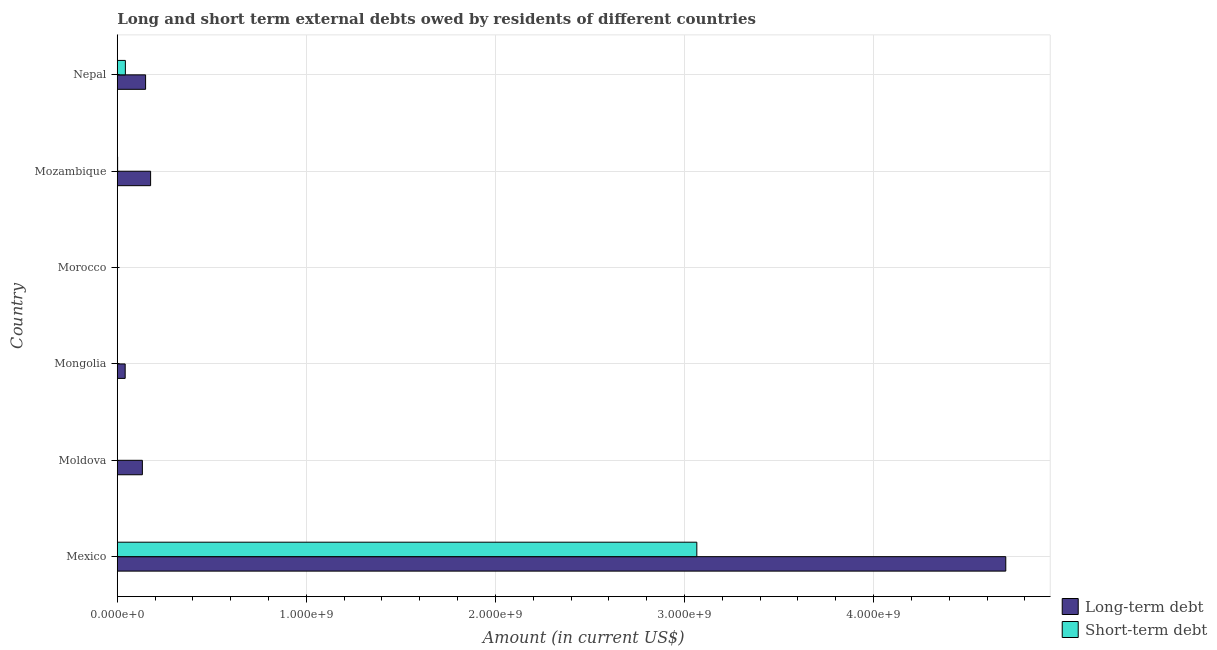What is the label of the 6th group of bars from the top?
Your answer should be compact. Mexico. In how many cases, is the number of bars for a given country not equal to the number of legend labels?
Offer a terse response. 2. What is the long-term debts owed by residents in Moldova?
Make the answer very short. 1.33e+08. Across all countries, what is the maximum short-term debts owed by residents?
Offer a very short reply. 3.07e+09. Across all countries, what is the minimum short-term debts owed by residents?
Your answer should be compact. 0. What is the total short-term debts owed by residents in the graph?
Provide a short and direct response. 3.11e+09. What is the difference between the long-term debts owed by residents in Moldova and that in Mozambique?
Offer a terse response. -4.35e+07. What is the difference between the long-term debts owed by residents in Moldova and the short-term debts owed by residents in Morocco?
Make the answer very short. 1.33e+08. What is the average short-term debts owed by residents per country?
Provide a short and direct response. 5.18e+08. What is the difference between the long-term debts owed by residents and short-term debts owed by residents in Mexico?
Offer a very short reply. 1.63e+09. What is the ratio of the long-term debts owed by residents in Mongolia to that in Mozambique?
Offer a terse response. 0.24. What is the difference between the highest and the second highest long-term debts owed by residents?
Give a very brief answer. 4.52e+09. What is the difference between the highest and the lowest long-term debts owed by residents?
Offer a terse response. 4.70e+09. In how many countries, is the long-term debts owed by residents greater than the average long-term debts owed by residents taken over all countries?
Keep it short and to the point. 1. Is the sum of the long-term debts owed by residents in Moldova and Mongolia greater than the maximum short-term debts owed by residents across all countries?
Your response must be concise. No. Are all the bars in the graph horizontal?
Your answer should be very brief. Yes. How many countries are there in the graph?
Your response must be concise. 6. What is the difference between two consecutive major ticks on the X-axis?
Offer a very short reply. 1.00e+09. Are the values on the major ticks of X-axis written in scientific E-notation?
Provide a succinct answer. Yes. Does the graph contain any zero values?
Your answer should be very brief. Yes. Does the graph contain grids?
Make the answer very short. Yes. What is the title of the graph?
Provide a short and direct response. Long and short term external debts owed by residents of different countries. What is the label or title of the X-axis?
Offer a terse response. Amount (in current US$). What is the Amount (in current US$) in Long-term debt in Mexico?
Provide a succinct answer. 4.70e+09. What is the Amount (in current US$) of Short-term debt in Mexico?
Offer a terse response. 3.07e+09. What is the Amount (in current US$) of Long-term debt in Moldova?
Ensure brevity in your answer.  1.33e+08. What is the Amount (in current US$) of Short-term debt in Moldova?
Make the answer very short. 1.00e+06. What is the Amount (in current US$) of Long-term debt in Mongolia?
Give a very brief answer. 4.17e+07. What is the Amount (in current US$) of Short-term debt in Mongolia?
Provide a short and direct response. 0. What is the Amount (in current US$) of Long-term debt in Mozambique?
Give a very brief answer. 1.76e+08. What is the Amount (in current US$) in Short-term debt in Mozambique?
Offer a very short reply. 1.80e+06. What is the Amount (in current US$) in Long-term debt in Nepal?
Ensure brevity in your answer.  1.50e+08. What is the Amount (in current US$) in Short-term debt in Nepal?
Provide a succinct answer. 4.28e+07. Across all countries, what is the maximum Amount (in current US$) of Long-term debt?
Provide a succinct answer. 4.70e+09. Across all countries, what is the maximum Amount (in current US$) of Short-term debt?
Ensure brevity in your answer.  3.07e+09. What is the total Amount (in current US$) of Long-term debt in the graph?
Your response must be concise. 5.20e+09. What is the total Amount (in current US$) of Short-term debt in the graph?
Your response must be concise. 3.11e+09. What is the difference between the Amount (in current US$) of Long-term debt in Mexico and that in Moldova?
Your answer should be very brief. 4.57e+09. What is the difference between the Amount (in current US$) in Short-term debt in Mexico and that in Moldova?
Offer a terse response. 3.06e+09. What is the difference between the Amount (in current US$) in Long-term debt in Mexico and that in Mongolia?
Your answer should be compact. 4.66e+09. What is the difference between the Amount (in current US$) in Long-term debt in Mexico and that in Mozambique?
Your answer should be compact. 4.52e+09. What is the difference between the Amount (in current US$) of Short-term debt in Mexico and that in Mozambique?
Keep it short and to the point. 3.06e+09. What is the difference between the Amount (in current US$) of Long-term debt in Mexico and that in Nepal?
Offer a very short reply. 4.55e+09. What is the difference between the Amount (in current US$) in Short-term debt in Mexico and that in Nepal?
Your response must be concise. 3.02e+09. What is the difference between the Amount (in current US$) of Long-term debt in Moldova and that in Mongolia?
Your response must be concise. 9.10e+07. What is the difference between the Amount (in current US$) of Long-term debt in Moldova and that in Mozambique?
Your answer should be very brief. -4.35e+07. What is the difference between the Amount (in current US$) in Short-term debt in Moldova and that in Mozambique?
Your answer should be very brief. -8.00e+05. What is the difference between the Amount (in current US$) in Long-term debt in Moldova and that in Nepal?
Make the answer very short. -1.70e+07. What is the difference between the Amount (in current US$) of Short-term debt in Moldova and that in Nepal?
Offer a terse response. -4.18e+07. What is the difference between the Amount (in current US$) in Long-term debt in Mongolia and that in Mozambique?
Your response must be concise. -1.35e+08. What is the difference between the Amount (in current US$) in Long-term debt in Mongolia and that in Nepal?
Provide a succinct answer. -1.08e+08. What is the difference between the Amount (in current US$) in Long-term debt in Mozambique and that in Nepal?
Give a very brief answer. 2.65e+07. What is the difference between the Amount (in current US$) of Short-term debt in Mozambique and that in Nepal?
Provide a succinct answer. -4.10e+07. What is the difference between the Amount (in current US$) of Long-term debt in Mexico and the Amount (in current US$) of Short-term debt in Moldova?
Give a very brief answer. 4.70e+09. What is the difference between the Amount (in current US$) of Long-term debt in Mexico and the Amount (in current US$) of Short-term debt in Mozambique?
Give a very brief answer. 4.70e+09. What is the difference between the Amount (in current US$) in Long-term debt in Mexico and the Amount (in current US$) in Short-term debt in Nepal?
Ensure brevity in your answer.  4.66e+09. What is the difference between the Amount (in current US$) in Long-term debt in Moldova and the Amount (in current US$) in Short-term debt in Mozambique?
Provide a short and direct response. 1.31e+08. What is the difference between the Amount (in current US$) of Long-term debt in Moldova and the Amount (in current US$) of Short-term debt in Nepal?
Ensure brevity in your answer.  8.99e+07. What is the difference between the Amount (in current US$) of Long-term debt in Mongolia and the Amount (in current US$) of Short-term debt in Mozambique?
Your answer should be compact. 3.99e+07. What is the difference between the Amount (in current US$) of Long-term debt in Mongolia and the Amount (in current US$) of Short-term debt in Nepal?
Give a very brief answer. -1.10e+06. What is the difference between the Amount (in current US$) in Long-term debt in Mozambique and the Amount (in current US$) in Short-term debt in Nepal?
Ensure brevity in your answer.  1.33e+08. What is the average Amount (in current US$) in Long-term debt per country?
Your answer should be very brief. 8.67e+08. What is the average Amount (in current US$) of Short-term debt per country?
Offer a terse response. 5.18e+08. What is the difference between the Amount (in current US$) in Long-term debt and Amount (in current US$) in Short-term debt in Mexico?
Give a very brief answer. 1.63e+09. What is the difference between the Amount (in current US$) in Long-term debt and Amount (in current US$) in Short-term debt in Moldova?
Your answer should be compact. 1.32e+08. What is the difference between the Amount (in current US$) in Long-term debt and Amount (in current US$) in Short-term debt in Mozambique?
Your response must be concise. 1.74e+08. What is the difference between the Amount (in current US$) of Long-term debt and Amount (in current US$) of Short-term debt in Nepal?
Provide a succinct answer. 1.07e+08. What is the ratio of the Amount (in current US$) in Long-term debt in Mexico to that in Moldova?
Offer a very short reply. 35.4. What is the ratio of the Amount (in current US$) of Short-term debt in Mexico to that in Moldova?
Your response must be concise. 3065.2. What is the ratio of the Amount (in current US$) in Long-term debt in Mexico to that in Mongolia?
Offer a very short reply. 112.68. What is the ratio of the Amount (in current US$) of Long-term debt in Mexico to that in Mozambique?
Offer a very short reply. 26.66. What is the ratio of the Amount (in current US$) in Short-term debt in Mexico to that in Mozambique?
Make the answer very short. 1702.89. What is the ratio of the Amount (in current US$) of Long-term debt in Mexico to that in Nepal?
Offer a terse response. 31.38. What is the ratio of the Amount (in current US$) of Short-term debt in Mexico to that in Nepal?
Ensure brevity in your answer.  71.6. What is the ratio of the Amount (in current US$) of Long-term debt in Moldova to that in Mongolia?
Make the answer very short. 3.18. What is the ratio of the Amount (in current US$) of Long-term debt in Moldova to that in Mozambique?
Offer a terse response. 0.75. What is the ratio of the Amount (in current US$) in Short-term debt in Moldova to that in Mozambique?
Provide a short and direct response. 0.56. What is the ratio of the Amount (in current US$) in Long-term debt in Moldova to that in Nepal?
Provide a succinct answer. 0.89. What is the ratio of the Amount (in current US$) in Short-term debt in Moldova to that in Nepal?
Your response must be concise. 0.02. What is the ratio of the Amount (in current US$) in Long-term debt in Mongolia to that in Mozambique?
Make the answer very short. 0.24. What is the ratio of the Amount (in current US$) of Long-term debt in Mongolia to that in Nepal?
Keep it short and to the point. 0.28. What is the ratio of the Amount (in current US$) of Long-term debt in Mozambique to that in Nepal?
Make the answer very short. 1.18. What is the ratio of the Amount (in current US$) of Short-term debt in Mozambique to that in Nepal?
Your answer should be compact. 0.04. What is the difference between the highest and the second highest Amount (in current US$) of Long-term debt?
Your answer should be compact. 4.52e+09. What is the difference between the highest and the second highest Amount (in current US$) in Short-term debt?
Offer a very short reply. 3.02e+09. What is the difference between the highest and the lowest Amount (in current US$) in Long-term debt?
Your answer should be compact. 4.70e+09. What is the difference between the highest and the lowest Amount (in current US$) in Short-term debt?
Make the answer very short. 3.07e+09. 